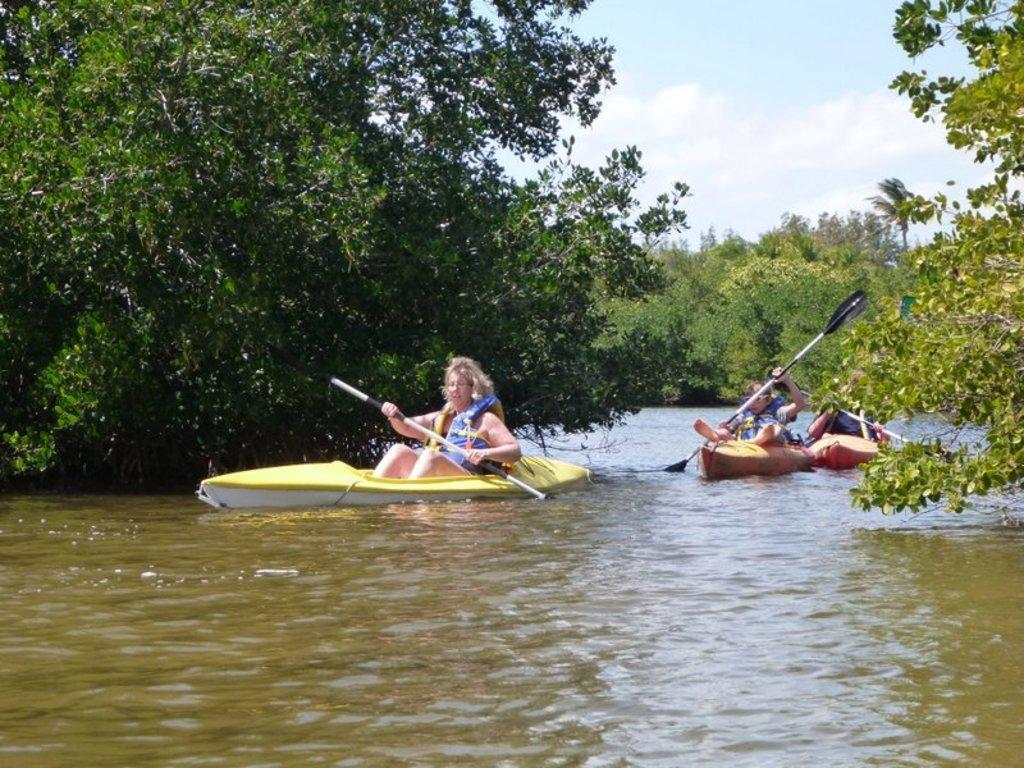In one or two sentences, can you explain what this image depicts? In this image we can see three people sitting in the boats holding the rows in a large water body. We can also see a group of trees and the sky which looks cloudy. 